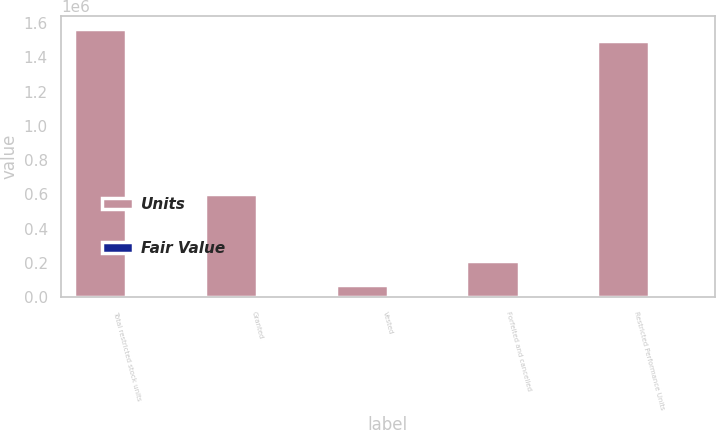<chart> <loc_0><loc_0><loc_500><loc_500><stacked_bar_chart><ecel><fcel>Total restricted stock units<fcel>Granted<fcel>Vested<fcel>Forfeited and cancelled<fcel>Restricted Performance Units<nl><fcel>Units<fcel>1.56433e+06<fcel>600000<fcel>69875<fcel>212077<fcel>1.49446e+06<nl><fcel>Fair Value<fcel>23<fcel>18.15<fcel>31.36<fcel>23.77<fcel>22.61<nl></chart> 